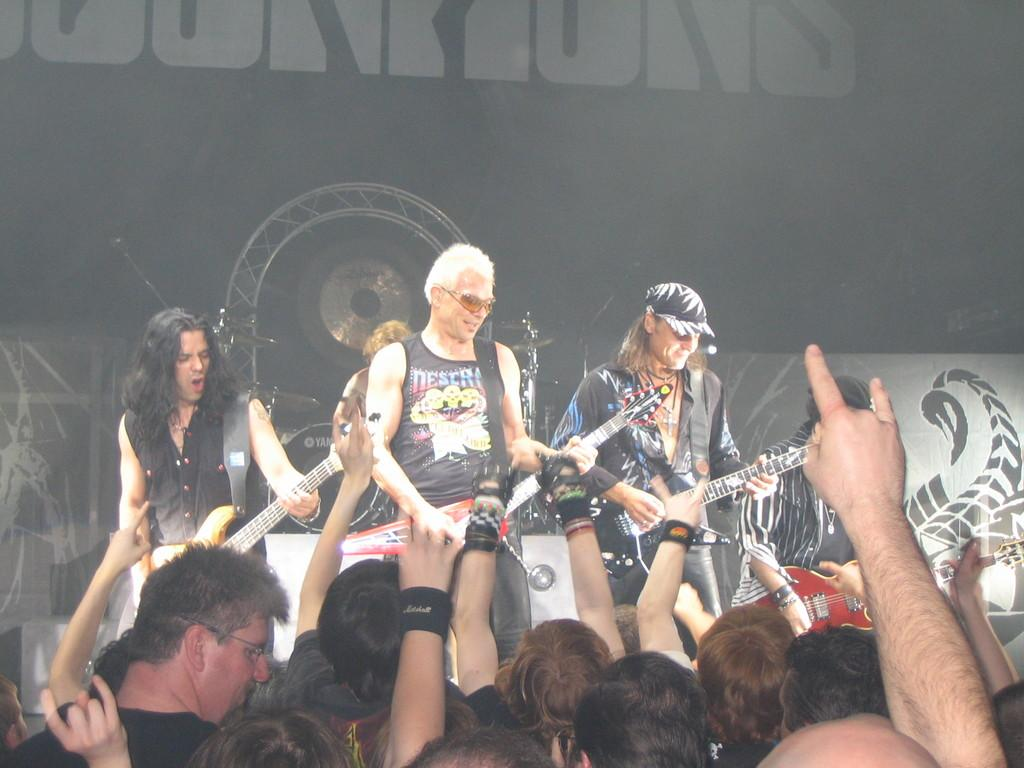How many men are in the image? There are 4 men in the image. What are the men doing in the image? The men are standing and holding guitars. Can you describe the overall scene in the image? There are many people in the image, and one person in the background is holding drums. What type of comb is being used by the person in the image? There is no comb present in the image. Is the image taken on a farm? The provided facts do not mention anything about a farm, so we cannot determine if the image was taken on a farm. 